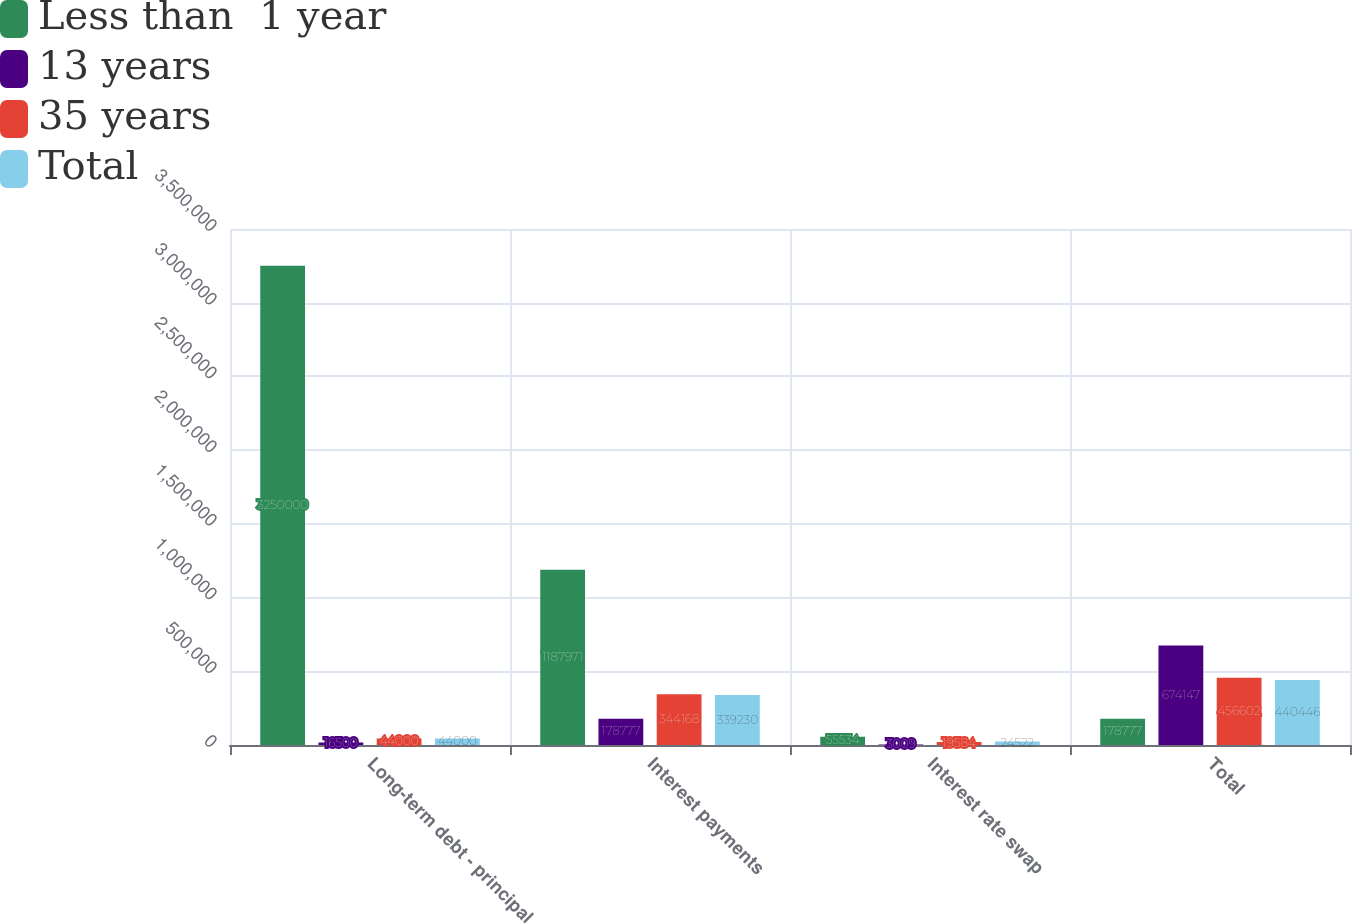Convert chart to OTSL. <chart><loc_0><loc_0><loc_500><loc_500><stacked_bar_chart><ecel><fcel>Long-term debt - principal<fcel>Interest payments<fcel>Interest rate swap<fcel>Total<nl><fcel>Less than  1 year<fcel>3.25e+06<fcel>1.18797e+06<fcel>55534<fcel>178777<nl><fcel>13 years<fcel>16500<fcel>178777<fcel>3009<fcel>674147<nl><fcel>35 years<fcel>44000<fcel>344168<fcel>19584<fcel>456602<nl><fcel>Total<fcel>44000<fcel>339230<fcel>24522<fcel>440446<nl></chart> 